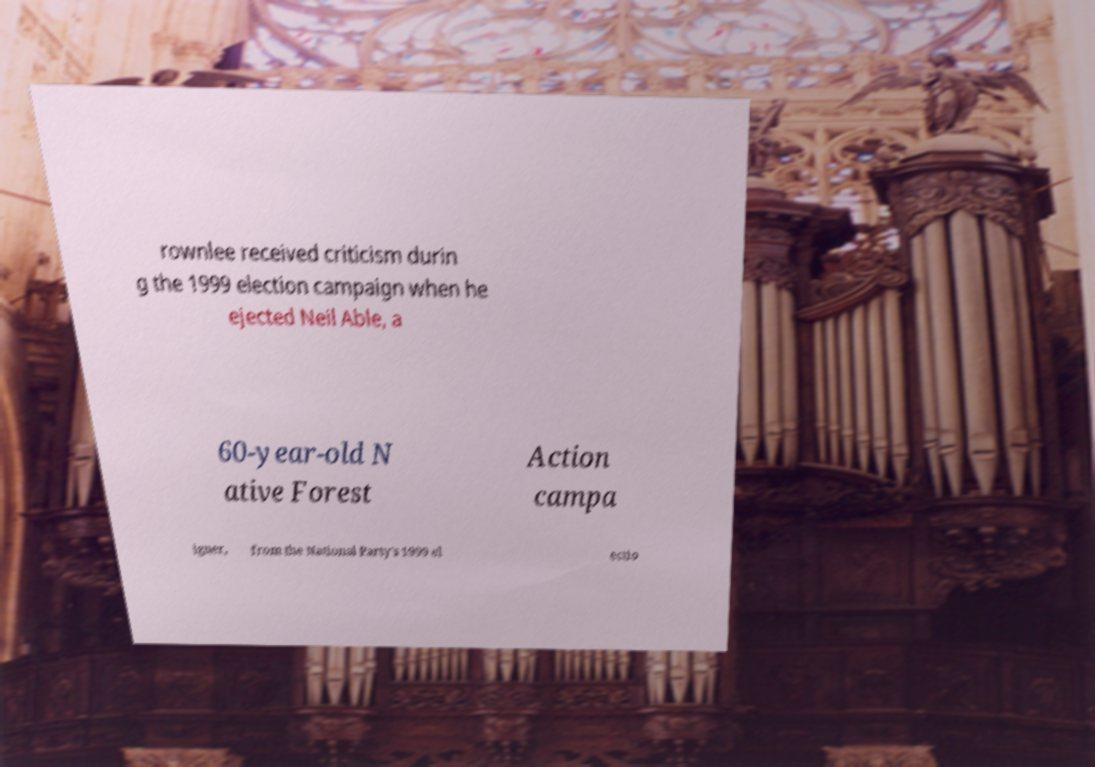Please identify and transcribe the text found in this image. rownlee received criticism durin g the 1999 election campaign when he ejected Neil Able, a 60-year-old N ative Forest Action campa igner, from the National Party's 1999 el ectio 